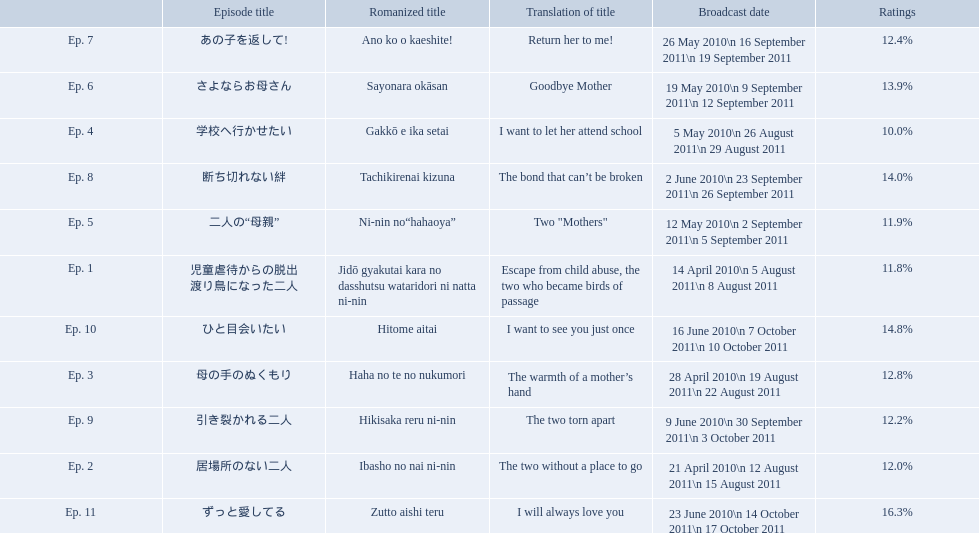Which episode was titled the two without a place to go? Ep. 2. What was the title of ep. 3? The warmth of a mother’s hand. Which episode had a rating of 10.0%? Ep. 4. 